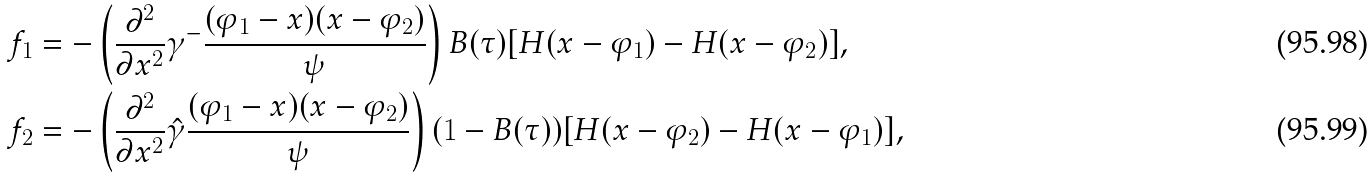Convert formula to latex. <formula><loc_0><loc_0><loc_500><loc_500>f _ { 1 } & = - \left ( \frac { \partial ^ { 2 } } { \partial x ^ { 2 } } \gamma ^ { - } \frac { ( \varphi _ { 1 } - x ) ( x - \varphi _ { 2 } ) } { \psi } \right ) B ( \tau ) [ H ( x - \varphi _ { 1 } ) - H ( x - \varphi _ { 2 } ) ] , \\ f _ { 2 } & = - \left ( \frac { \partial ^ { 2 } } { \partial x ^ { 2 } } \hat { \gamma } \frac { ( \varphi _ { 1 } - x ) ( x - \varphi _ { 2 } ) } { \psi } \right ) ( 1 - B ( \tau ) ) [ H ( x - \varphi _ { 2 } ) - H ( x - \varphi _ { 1 } ) ] ,</formula> 